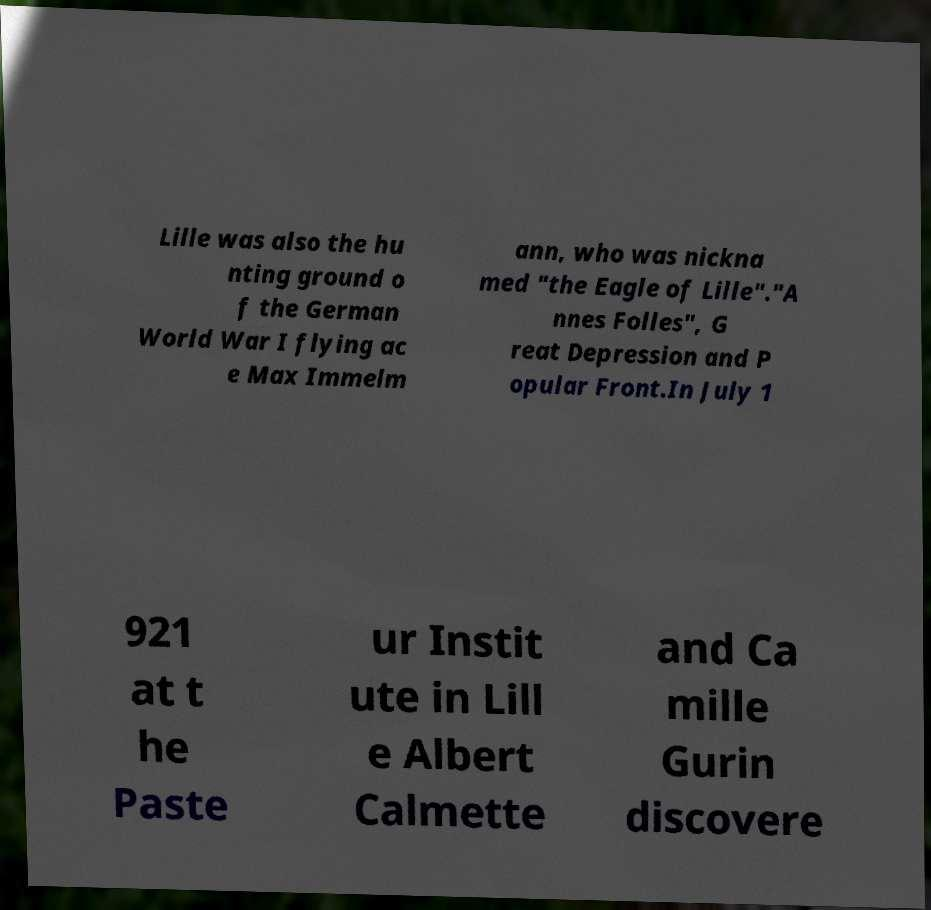Can you accurately transcribe the text from the provided image for me? Lille was also the hu nting ground o f the German World War I flying ac e Max Immelm ann, who was nickna med "the Eagle of Lille"."A nnes Folles", G reat Depression and P opular Front.In July 1 921 at t he Paste ur Instit ute in Lill e Albert Calmette and Ca mille Gurin discovere 